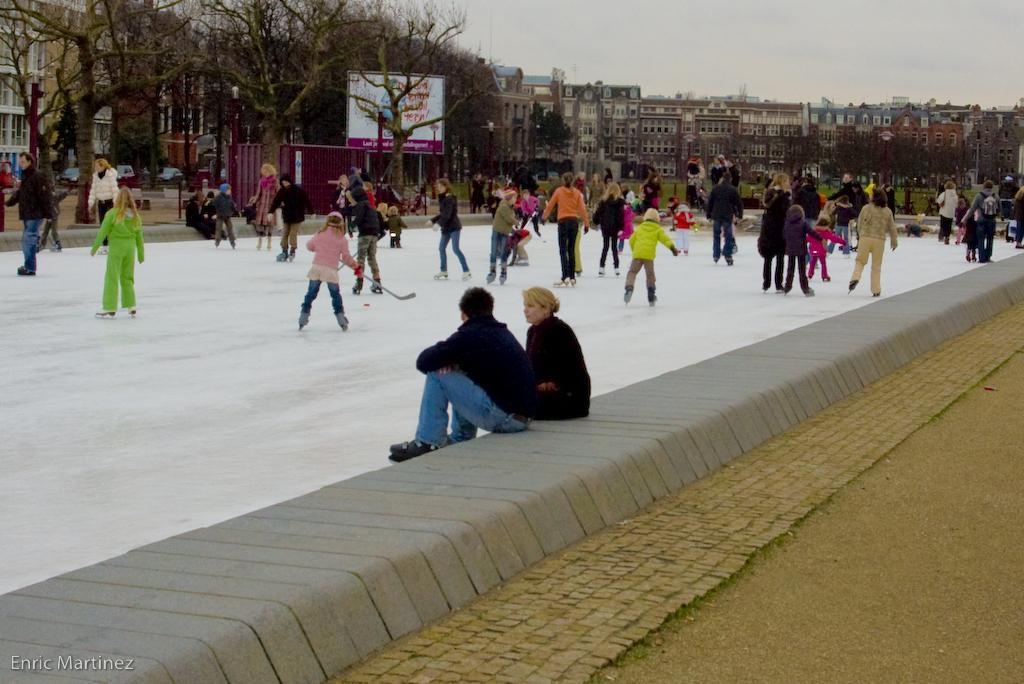Could you give a brief overview of what you see in this image? In this picture there are group of people skating. In the foreground there are two persons sitting on the wall. At the back there are buildings and trees and there is a hoarding. At the top there is sky. At the bottom left there is a text. 